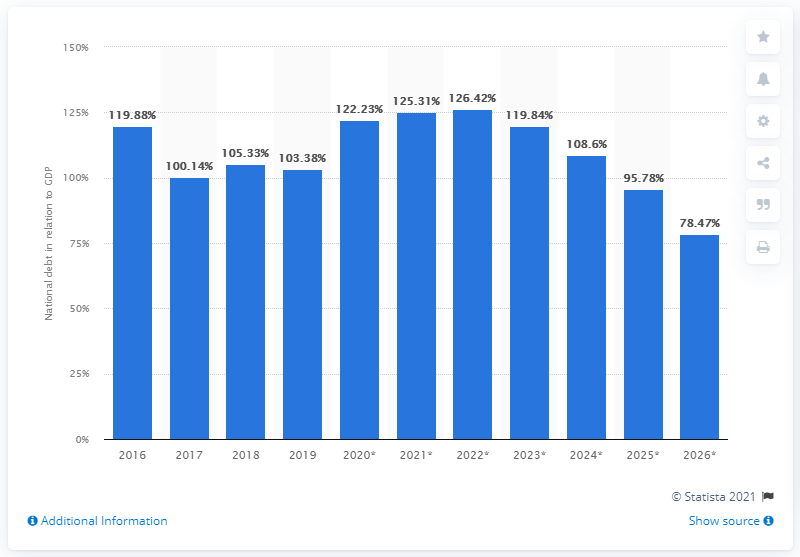Point out several critical features in this image. In 2019, Mozambique's national debt represented approximately 66.8% of the country's Gross Domestic Product (GDP). 